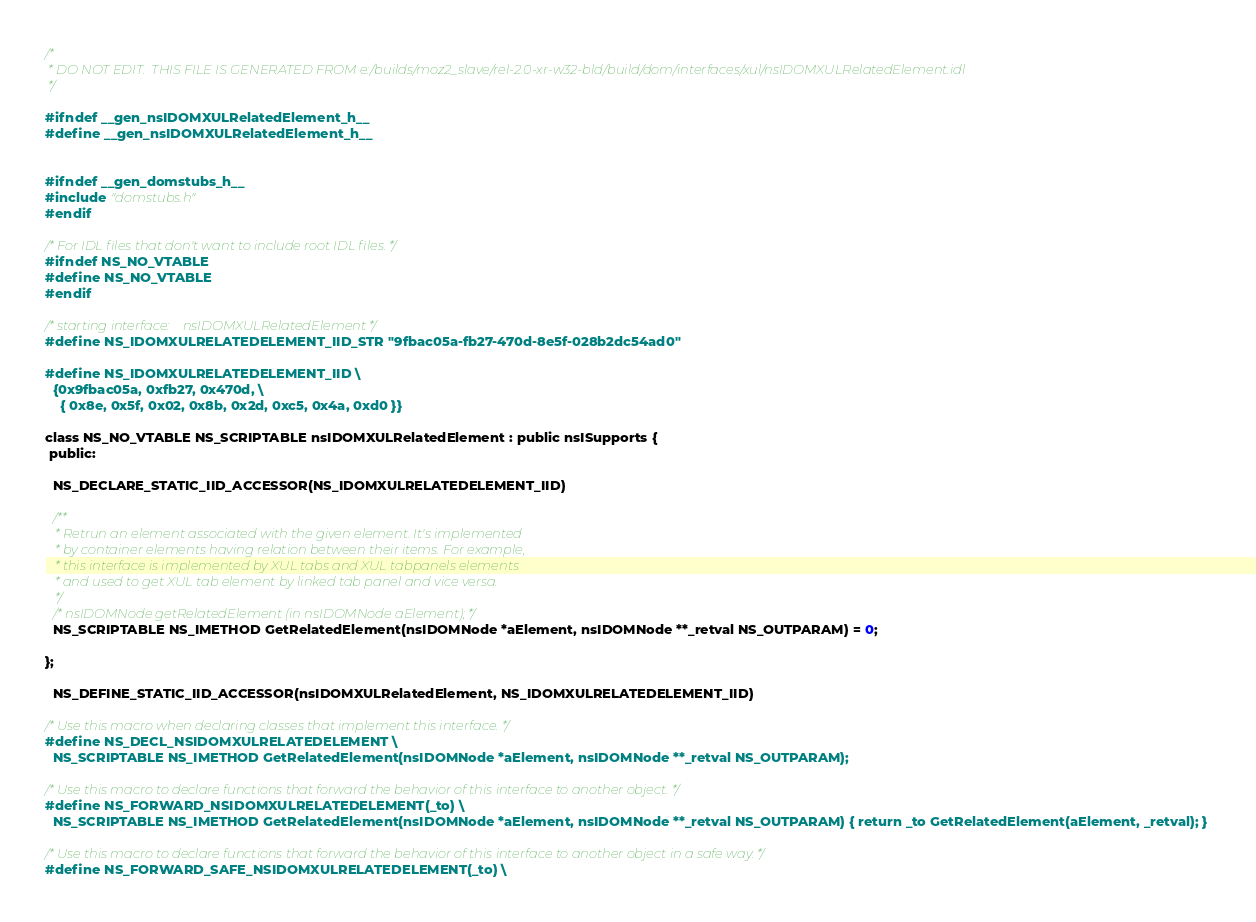Convert code to text. <code><loc_0><loc_0><loc_500><loc_500><_C_>/*
 * DO NOT EDIT.  THIS FILE IS GENERATED FROM e:/builds/moz2_slave/rel-2.0-xr-w32-bld/build/dom/interfaces/xul/nsIDOMXULRelatedElement.idl
 */

#ifndef __gen_nsIDOMXULRelatedElement_h__
#define __gen_nsIDOMXULRelatedElement_h__


#ifndef __gen_domstubs_h__
#include "domstubs.h"
#endif

/* For IDL files that don't want to include root IDL files. */
#ifndef NS_NO_VTABLE
#define NS_NO_VTABLE
#endif

/* starting interface:    nsIDOMXULRelatedElement */
#define NS_IDOMXULRELATEDELEMENT_IID_STR "9fbac05a-fb27-470d-8e5f-028b2dc54ad0"

#define NS_IDOMXULRELATEDELEMENT_IID \
  {0x9fbac05a, 0xfb27, 0x470d, \
    { 0x8e, 0x5f, 0x02, 0x8b, 0x2d, 0xc5, 0x4a, 0xd0 }}

class NS_NO_VTABLE NS_SCRIPTABLE nsIDOMXULRelatedElement : public nsISupports {
 public: 

  NS_DECLARE_STATIC_IID_ACCESSOR(NS_IDOMXULRELATEDELEMENT_IID)

  /**
   * Retrun an element associated with the given element. It's implemented
   * by container elements having relation between their items. For example,
   * this interface is implemented by XUL tabs and XUL tabpanels elements
   * and used to get XUL tab element by linked tab panel and vice versa.
   */
  /* nsIDOMNode getRelatedElement (in nsIDOMNode aElement); */
  NS_SCRIPTABLE NS_IMETHOD GetRelatedElement(nsIDOMNode *aElement, nsIDOMNode **_retval NS_OUTPARAM) = 0;

};

  NS_DEFINE_STATIC_IID_ACCESSOR(nsIDOMXULRelatedElement, NS_IDOMXULRELATEDELEMENT_IID)

/* Use this macro when declaring classes that implement this interface. */
#define NS_DECL_NSIDOMXULRELATEDELEMENT \
  NS_SCRIPTABLE NS_IMETHOD GetRelatedElement(nsIDOMNode *aElement, nsIDOMNode **_retval NS_OUTPARAM); 

/* Use this macro to declare functions that forward the behavior of this interface to another object. */
#define NS_FORWARD_NSIDOMXULRELATEDELEMENT(_to) \
  NS_SCRIPTABLE NS_IMETHOD GetRelatedElement(nsIDOMNode *aElement, nsIDOMNode **_retval NS_OUTPARAM) { return _to GetRelatedElement(aElement, _retval); } 

/* Use this macro to declare functions that forward the behavior of this interface to another object in a safe way. */
#define NS_FORWARD_SAFE_NSIDOMXULRELATEDELEMENT(_to) \</code> 